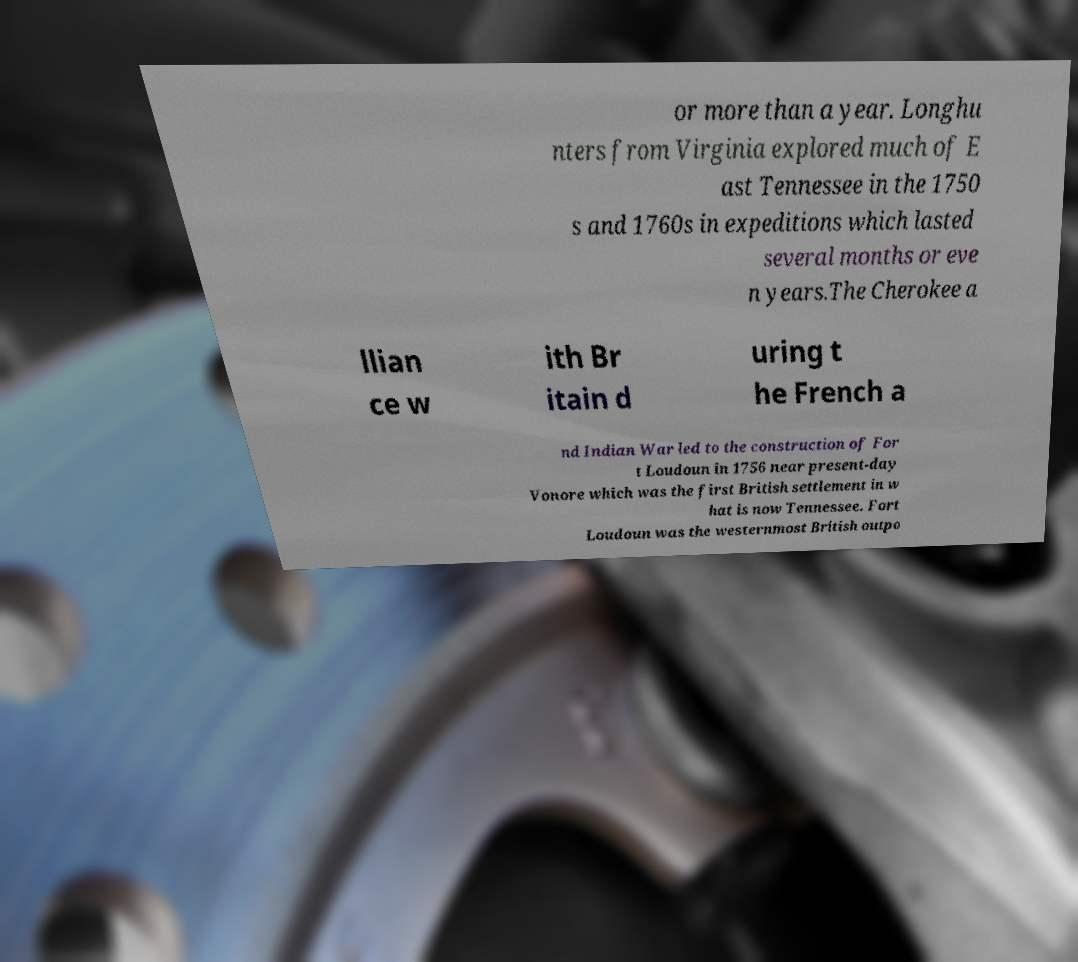Please read and relay the text visible in this image. What does it say? or more than a year. Longhu nters from Virginia explored much of E ast Tennessee in the 1750 s and 1760s in expeditions which lasted several months or eve n years.The Cherokee a llian ce w ith Br itain d uring t he French a nd Indian War led to the construction of For t Loudoun in 1756 near present-day Vonore which was the first British settlement in w hat is now Tennessee. Fort Loudoun was the westernmost British outpo 